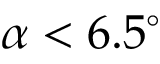Convert formula to latex. <formula><loc_0><loc_0><loc_500><loc_500>\alpha < 6 . 5 ^ { \circ }</formula> 